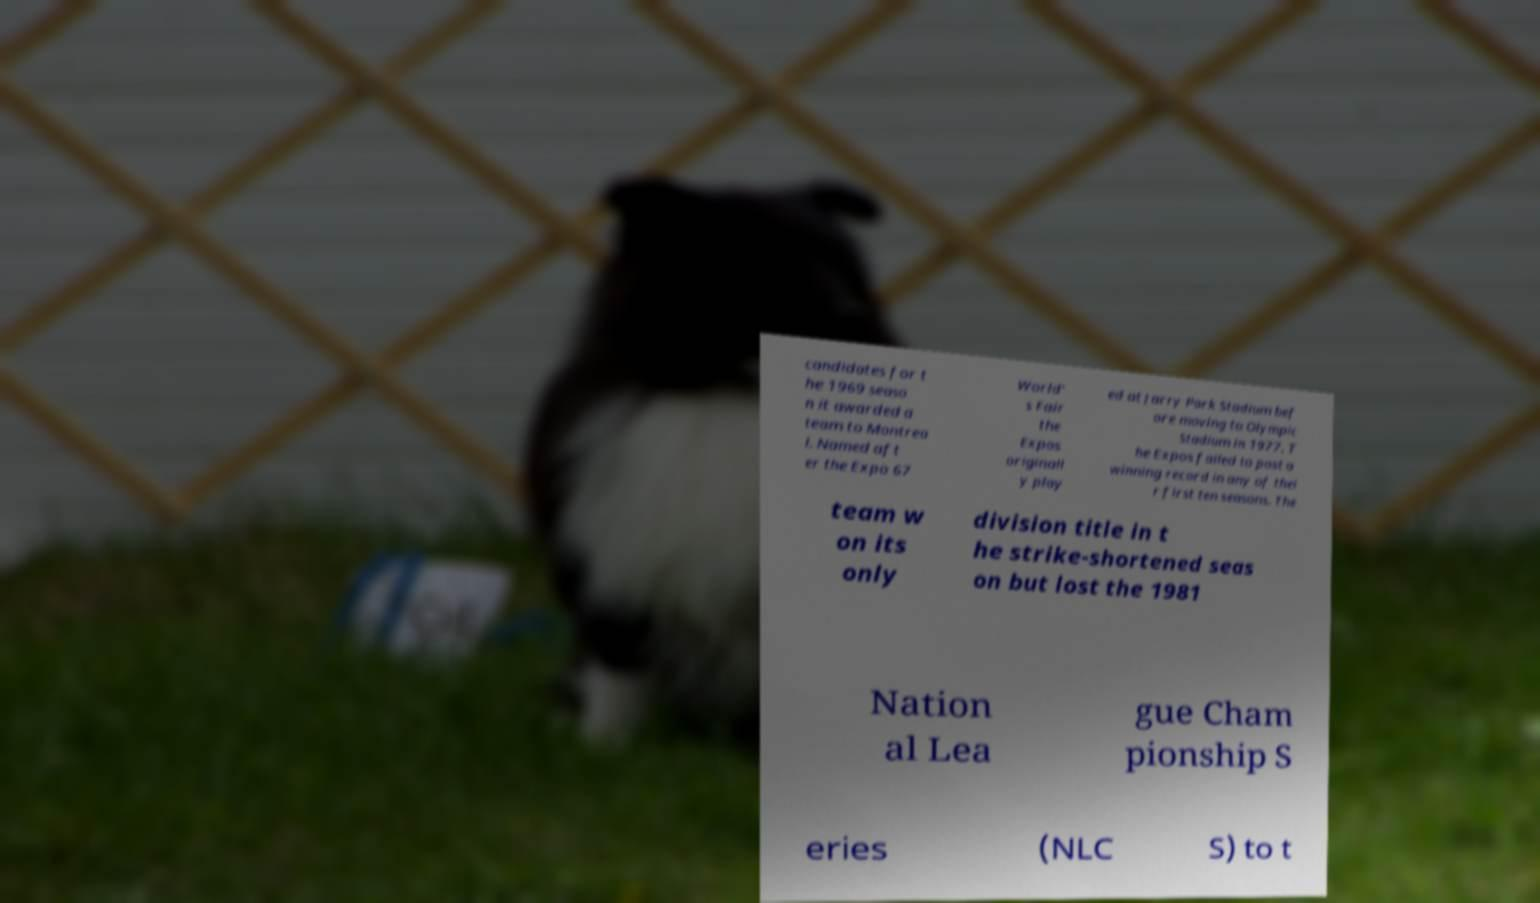Could you extract and type out the text from this image? candidates for t he 1969 seaso n it awarded a team to Montrea l. Named aft er the Expo 67 World' s Fair the Expos originall y play ed at Jarry Park Stadium bef ore moving to Olympic Stadium in 1977. T he Expos failed to post a winning record in any of thei r first ten seasons. The team w on its only division title in t he strike-shortened seas on but lost the 1981 Nation al Lea gue Cham pionship S eries (NLC S) to t 